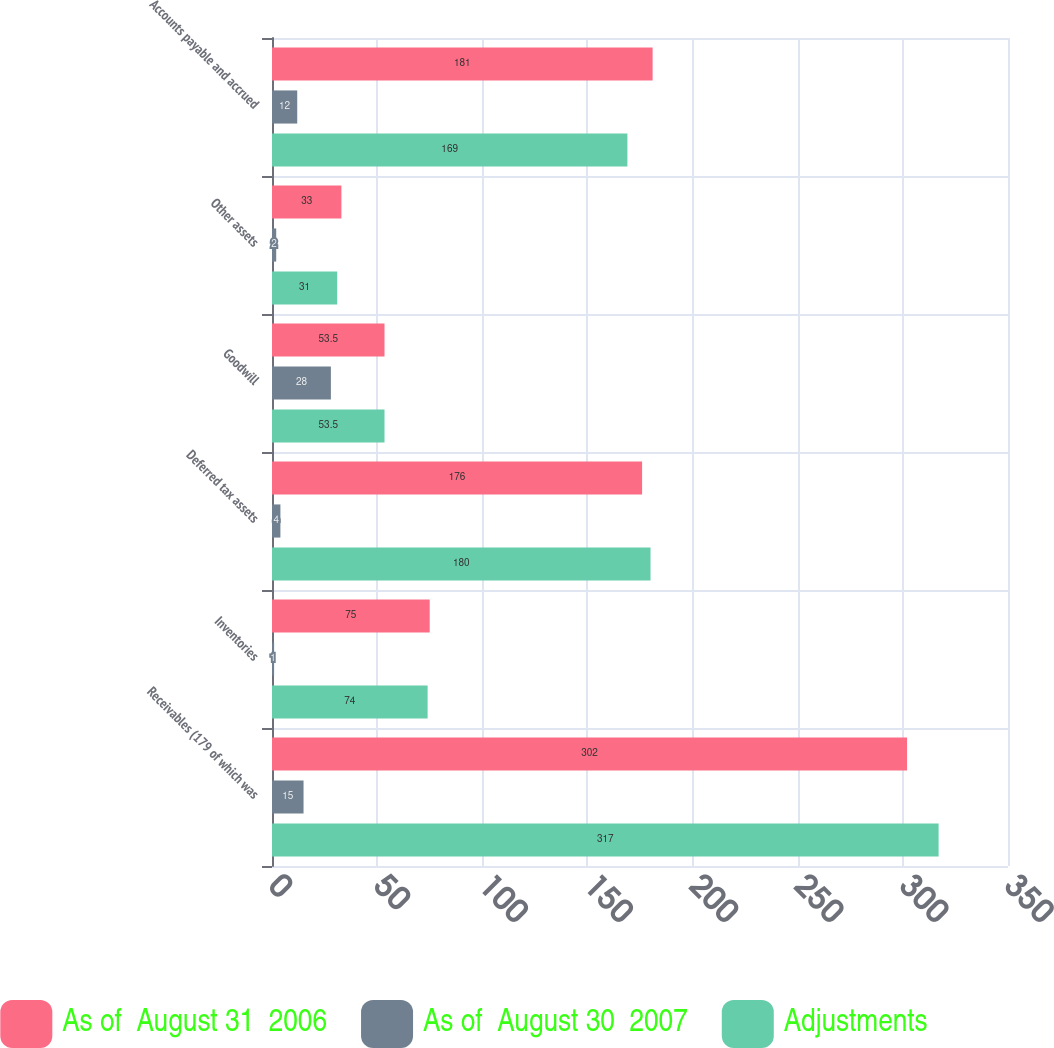Convert chart to OTSL. <chart><loc_0><loc_0><loc_500><loc_500><stacked_bar_chart><ecel><fcel>Receivables (179 of which was<fcel>Inventories<fcel>Deferred tax assets<fcel>Goodwill<fcel>Other assets<fcel>Accounts payable and accrued<nl><fcel>As of  August 31  2006<fcel>302<fcel>75<fcel>176<fcel>53.5<fcel>33<fcel>181<nl><fcel>As of  August 30  2007<fcel>15<fcel>1<fcel>4<fcel>28<fcel>2<fcel>12<nl><fcel>Adjustments<fcel>317<fcel>74<fcel>180<fcel>53.5<fcel>31<fcel>169<nl></chart> 